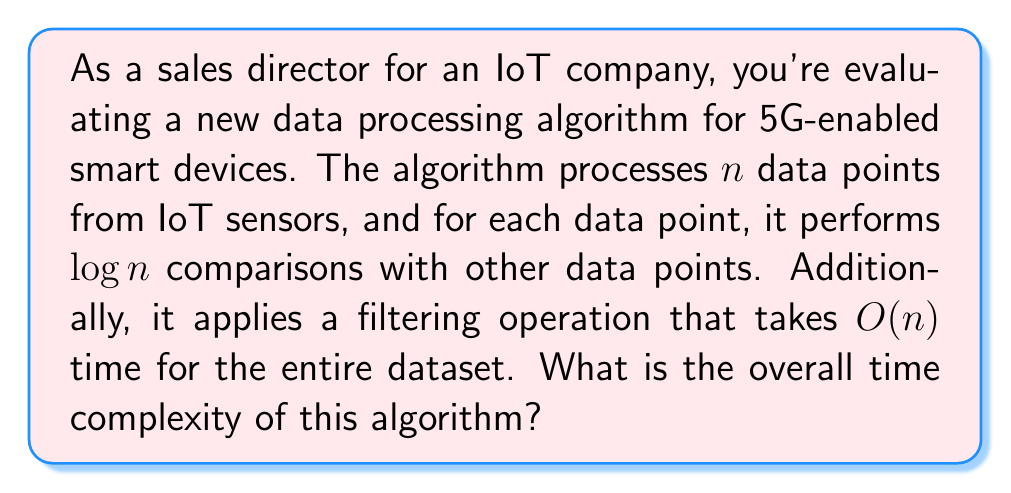Help me with this question. Let's break down the algorithm and analyze its time complexity step by step:

1. Processing $n$ data points:
   - For each data point, the algorithm performs $\log n$ comparisons.
   - This means for $n$ data points, we have $n \cdot \log n$ operations.
   - The time complexity for this part is $O(n \log n)$.

2. Filtering operation:
   - The filtering operation takes $O(n)$ time for the entire dataset.

3. Combining the two parts:
   - We need to add the time complexities of both parts.
   - $O(n \log n) + O(n)$

4. Simplifying the result:
   - Since $n \log n$ grows faster than $n$ for large values of $n$, we can simplify this to $O(n \log n)$.

In Big O notation, we always consider the dominant term, which in this case is $n \log n$.

Therefore, the overall time complexity of the algorithm is $O(n \log n)$.

This complexity is often seen in efficient sorting algorithms like Merge Sort or Heap Sort, which could be relevant for processing and organizing large amounts of IoT data in 5G-enabled smart devices.
Answer: $O(n \log n)$ 